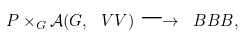<formula> <loc_0><loc_0><loc_500><loc_500>P \times _ { G } \mathcal { A } ( G , \ V V ) \longrightarrow \ B B B ,</formula> 